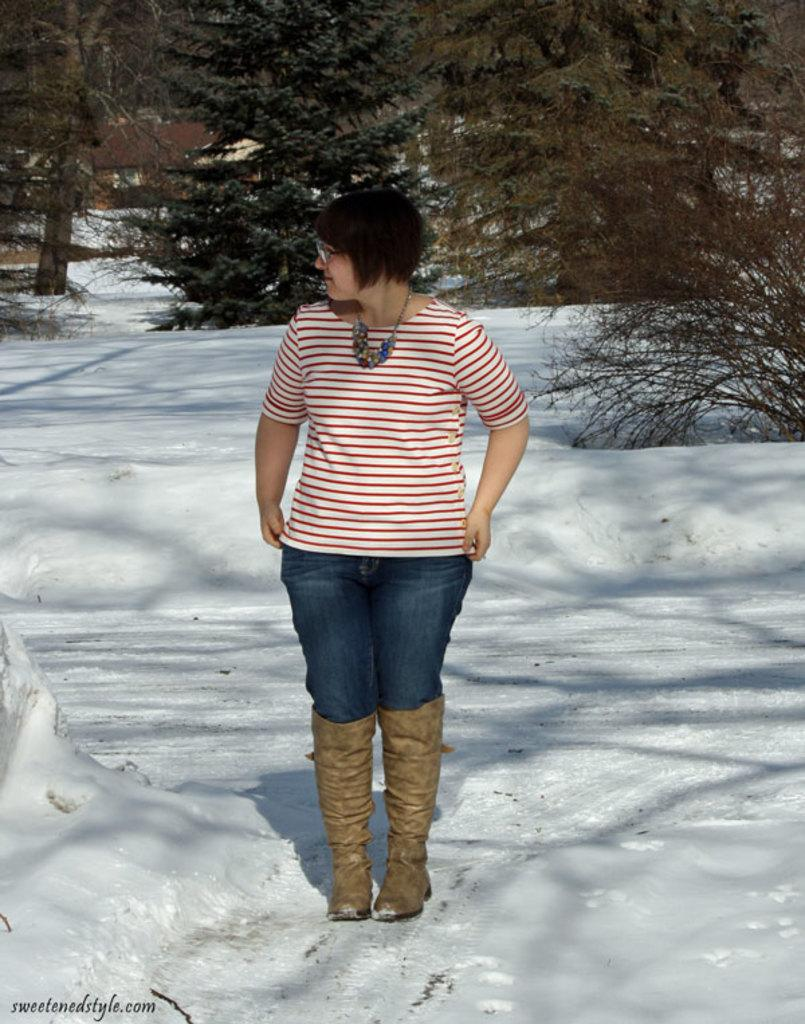What is the main subject of the image? There is a woman standing in the image. What can be seen under the woman's feet? The ground is visible in the image. What is the weather like in the image? There is snow in the image, indicating a cold and likely wintery environment. What type of vegetation is present in the image? There is a group of trees in the image. What type of structure is visible in the image? There is a house in the image. What type of sail can be seen on the woman's clothing in the image? There is no sail present on the woman's clothing in the image. Can you tell me how many donkeys are standing near the house in the image? There are no donkeys present in the image; it only features a woman, snow, trees, and a house. 